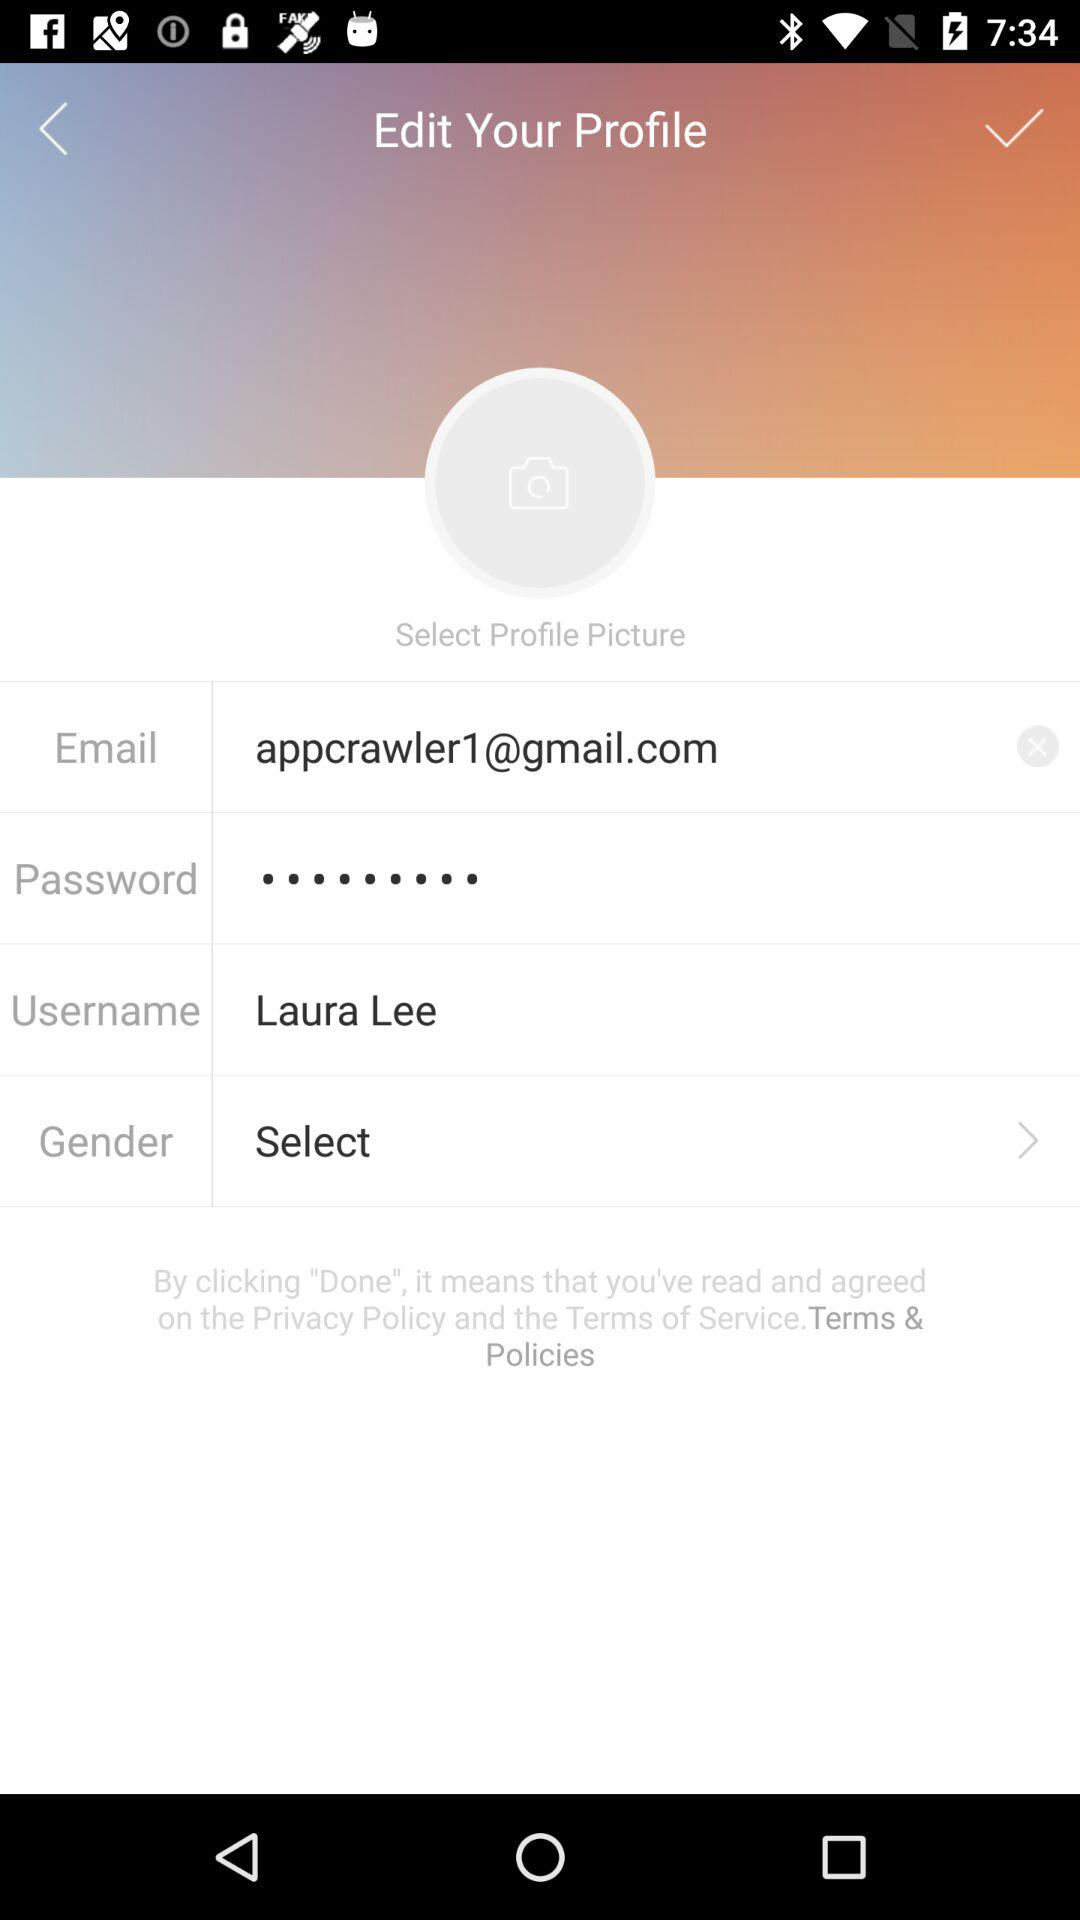What is the email address given? The given email address is appcrawler1@gmail.com. 